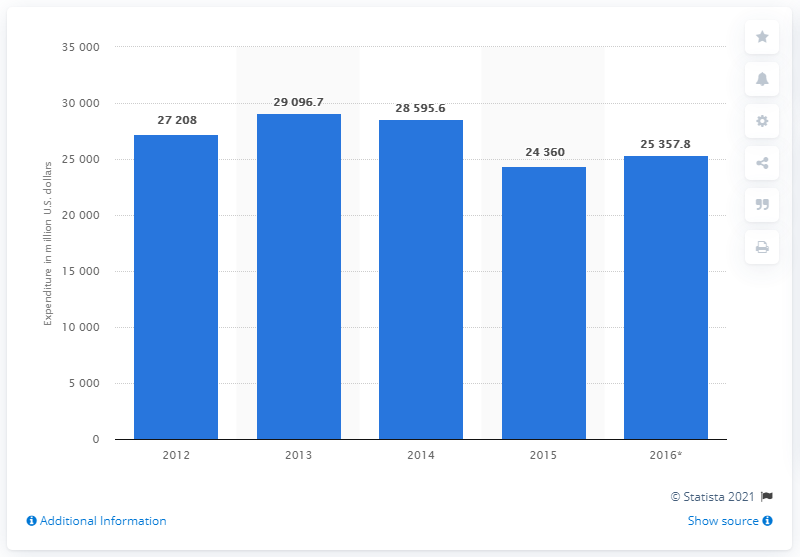Point out several critical features in this image. According to projections, Sweden is expected to spend 25,357.8 million euros on food in 2016. 